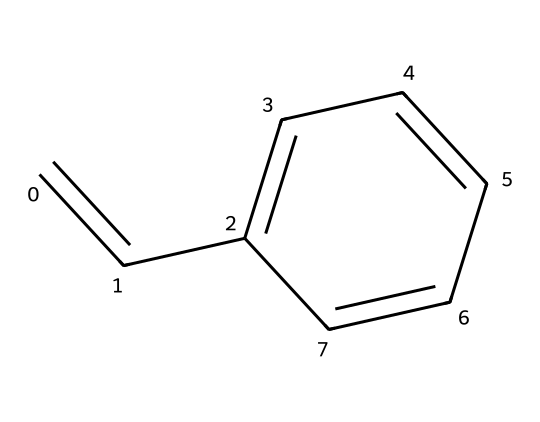What is the molecular formula of styrene? To derive the molecular formula, we count the carbon and hydrogen atoms in the structure. There are 8 carbon atoms (denoted by 'C') and 8 hydrogen atoms (denoted by 'H') in the structure, leading to the formula C8H8.
Answer: C8H8 How many double bonds are present in styrene? By examining the structure, we see one double bond between the first carbon atom and the second carbon atom, which qualifies as one double bond in the molecule.
Answer: 1 What type of molecule is styrene classified as? Styrene is classified as an aromatic hydrocarbon due to the presence of a benzene ring in its structure. The ring can be identified from the alternating double bonds, characteristic of aromatic compounds.
Answer: aromatic hydrocarbon What is the predominant functional group for styrene? Styrene primarily features a vinyl group, characterized by the presence of both a double bond between carbon atoms and the adjacent aromatic structure, making it a vinyl aromatic monomer.
Answer: vinyl group How many bonds are present between consecutive carbon atoms in styrene? In the chemical structure of styrene, consecutive carbon atoms are joined by either single or double bonds, totaling 7 bonds connecting the 8 individual carbon atoms (1 double bond and 6 single bonds).
Answer: 7 What does the presence of a benzene ring imply about styrene's stability? The benzene ring suggests that styrene has a higher degree of stability due to resonance, as the electrons are delocalized, allowing the structure to distribute energy over the molecule, promoting stability.
Answer: stability What is the significance of styrene being a monomer in construction adhesives? Styrene's significance lies in its ability to polymerize, forming long-chain compounds that enhance adhesive properties and provide strength, flexibility, and resistance, making it suitable for construction adhesives.
Answer: polymerization 